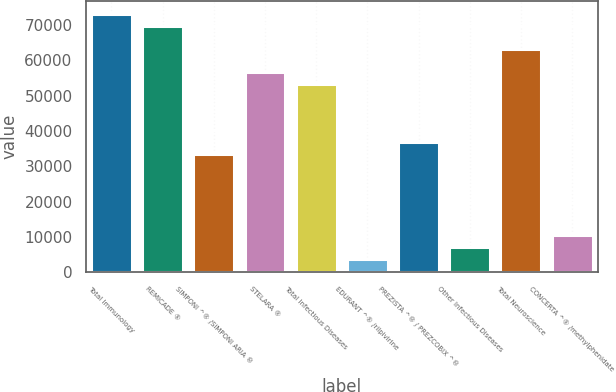Convert chart. <chart><loc_0><loc_0><loc_500><loc_500><bar_chart><fcel>Total Immunology<fcel>REMICADE ®<fcel>SIMPONI ^® /SIMPONI ARIA ®<fcel>STELARA ®<fcel>Total Infectious Diseases<fcel>EDURANT ^® /rilpivirine<fcel>PREZISTA ^® / PREZCOBIX ^®<fcel>Other Infectious Diseases<fcel>Total Neuroscience<fcel>CONCERTA ^® /methylphenidate<nl><fcel>73020.8<fcel>69724.4<fcel>33464<fcel>56538.8<fcel>53242.4<fcel>3796.4<fcel>36760.4<fcel>7092.8<fcel>63131.6<fcel>10389.2<nl></chart> 